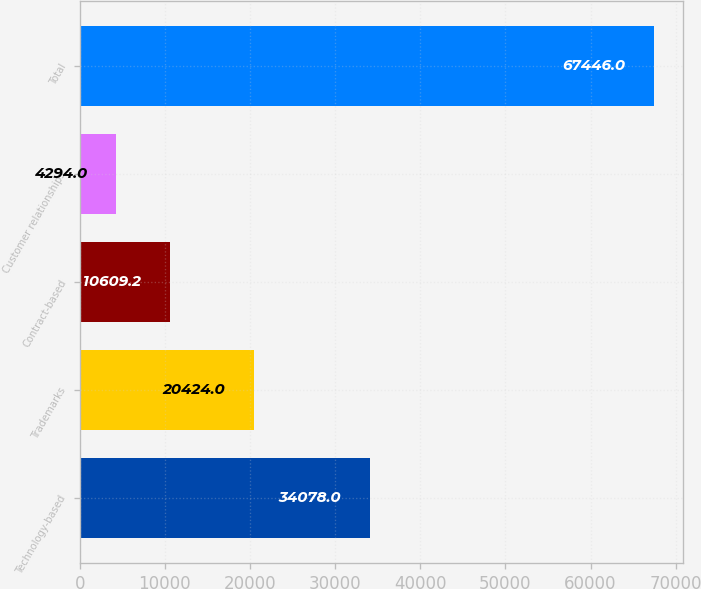Convert chart. <chart><loc_0><loc_0><loc_500><loc_500><bar_chart><fcel>Technology-based<fcel>Trademarks<fcel>Contract-based<fcel>Customer relationships<fcel>Total<nl><fcel>34078<fcel>20424<fcel>10609.2<fcel>4294<fcel>67446<nl></chart> 